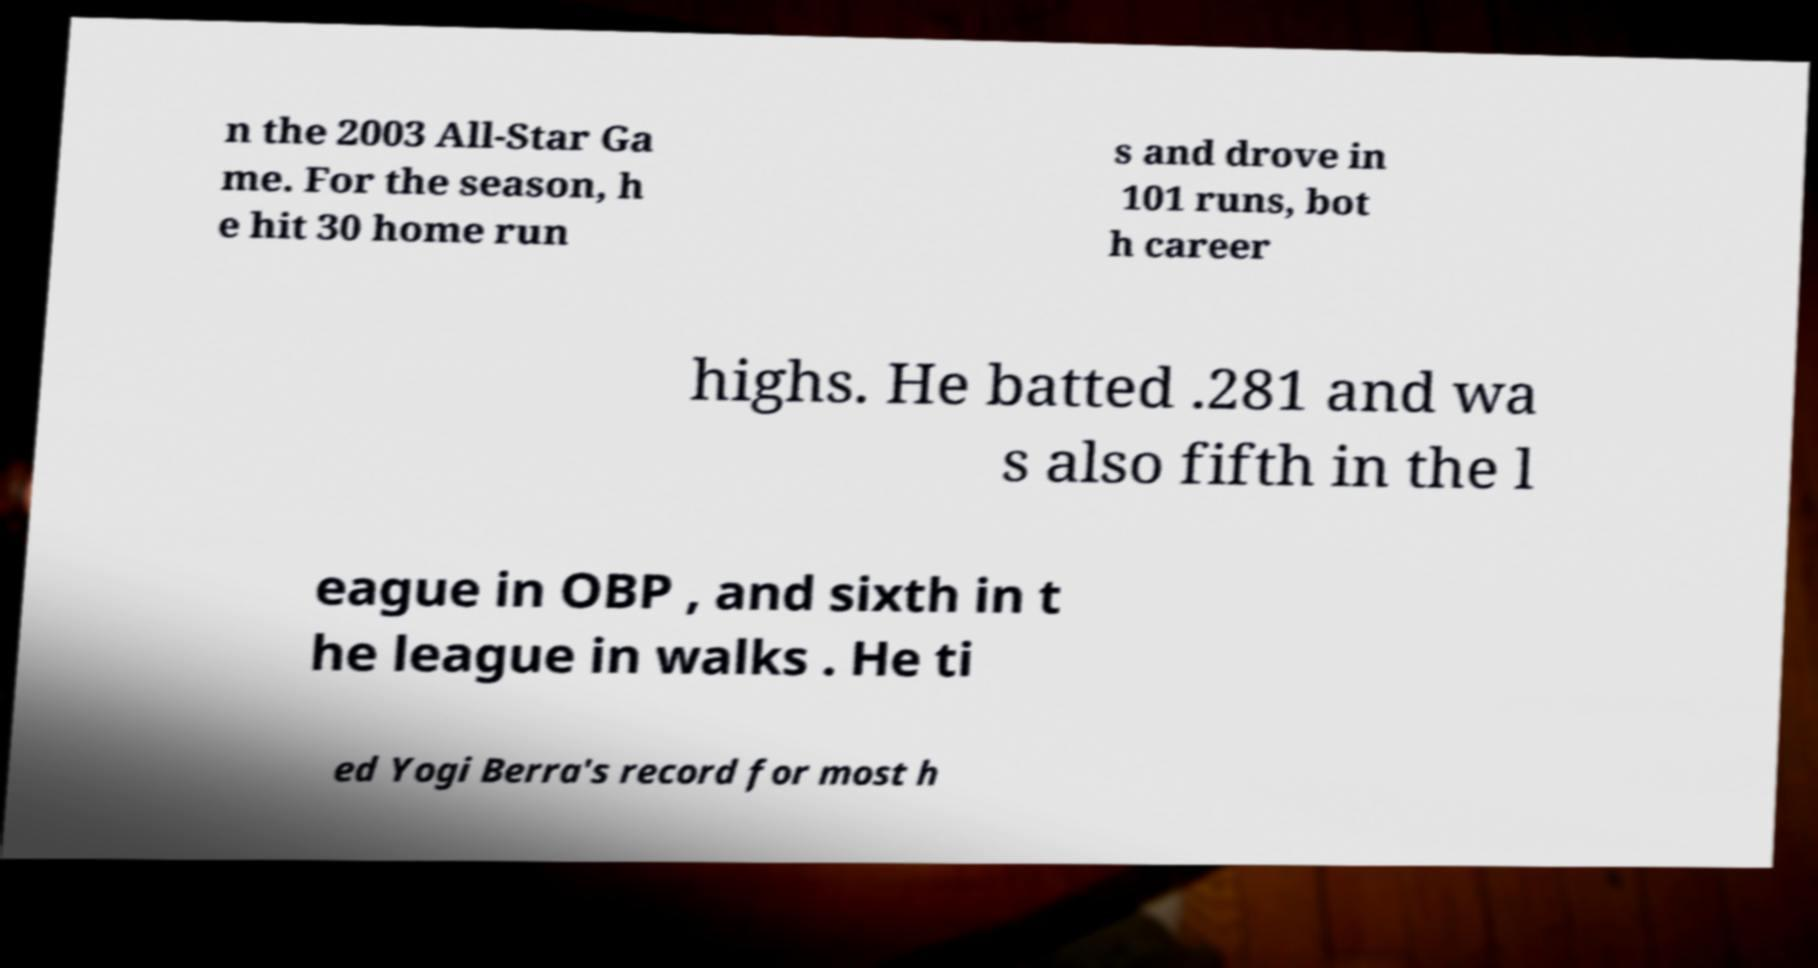Could you extract and type out the text from this image? n the 2003 All-Star Ga me. For the season, h e hit 30 home run s and drove in 101 runs, bot h career highs. He batted .281 and wa s also fifth in the l eague in OBP , and sixth in t he league in walks . He ti ed Yogi Berra's record for most h 